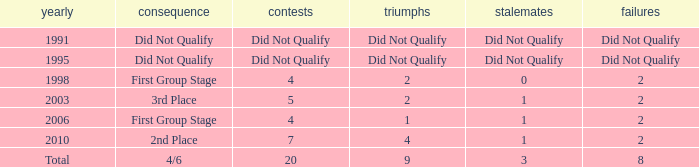How many draws were there in 2006? 1.0. 